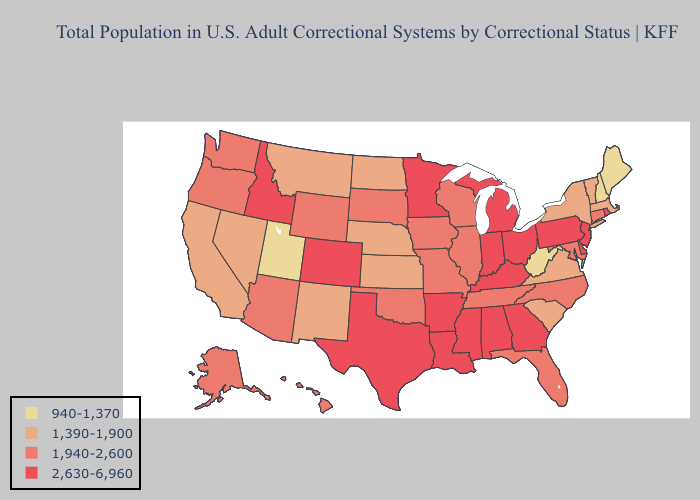Does Maryland have the lowest value in the USA?
Answer briefly. No. Does Connecticut have the highest value in the USA?
Give a very brief answer. No. Does New Jersey have the highest value in the USA?
Write a very short answer. Yes. What is the value of Florida?
Quick response, please. 1,940-2,600. Among the states that border Colorado , does Nebraska have the lowest value?
Write a very short answer. No. Which states hav the highest value in the West?
Be succinct. Colorado, Idaho. What is the value of Massachusetts?
Answer briefly. 1,390-1,900. What is the value of Ohio?
Give a very brief answer. 2,630-6,960. Does Alabama have the highest value in the USA?
Be succinct. Yes. Among the states that border Texas , which have the lowest value?
Be succinct. New Mexico. Does the first symbol in the legend represent the smallest category?
Be succinct. Yes. Which states have the lowest value in the USA?
Be succinct. Maine, New Hampshire, Utah, West Virginia. Name the states that have a value in the range 2,630-6,960?
Write a very short answer. Alabama, Arkansas, Colorado, Delaware, Georgia, Idaho, Indiana, Kentucky, Louisiana, Michigan, Minnesota, Mississippi, New Jersey, Ohio, Pennsylvania, Rhode Island, Texas. What is the lowest value in the USA?
Answer briefly. 940-1,370. What is the value of Illinois?
Concise answer only. 1,940-2,600. 